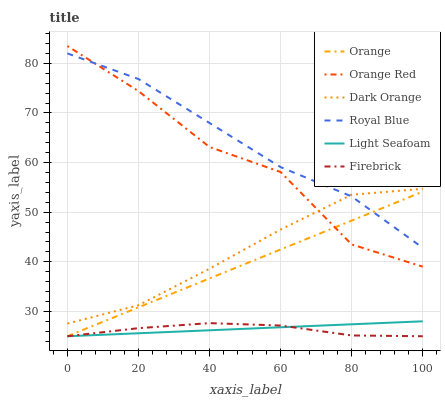Does Royal Blue have the minimum area under the curve?
Answer yes or no. No. Does Firebrick have the maximum area under the curve?
Answer yes or no. No. Is Firebrick the smoothest?
Answer yes or no. No. Is Firebrick the roughest?
Answer yes or no. No. Does Royal Blue have the lowest value?
Answer yes or no. No. Does Royal Blue have the highest value?
Answer yes or no. No. Is Firebrick less than Dark Orange?
Answer yes or no. Yes. Is Dark Orange greater than Firebrick?
Answer yes or no. Yes. Does Firebrick intersect Dark Orange?
Answer yes or no. No. 